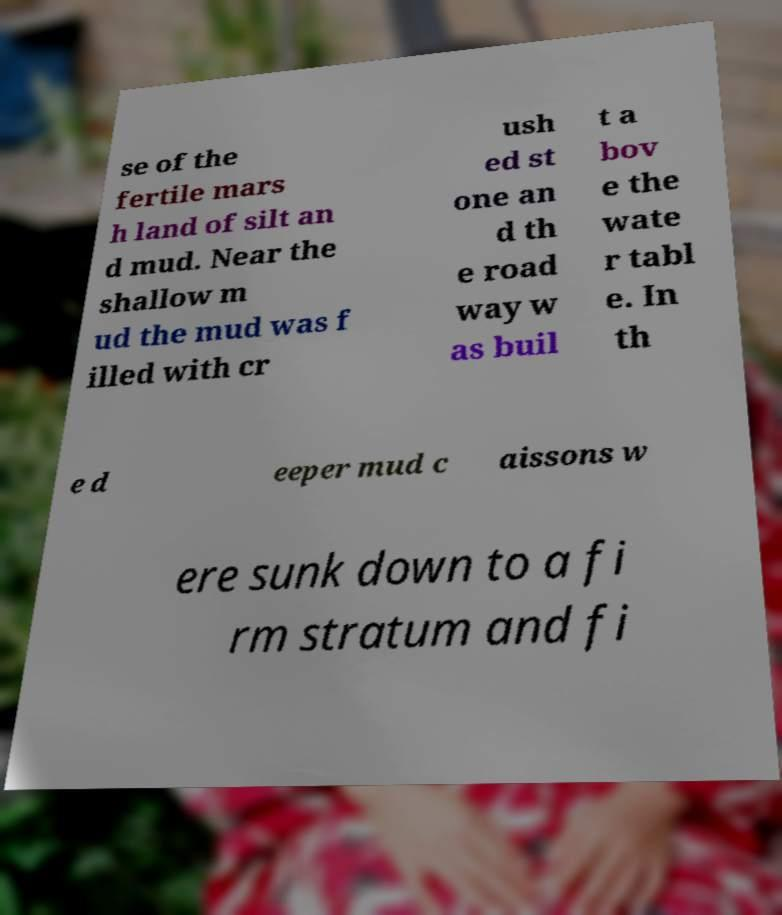Please identify and transcribe the text found in this image. se of the fertile mars h land of silt an d mud. Near the shallow m ud the mud was f illed with cr ush ed st one an d th e road way w as buil t a bov e the wate r tabl e. In th e d eeper mud c aissons w ere sunk down to a fi rm stratum and fi 